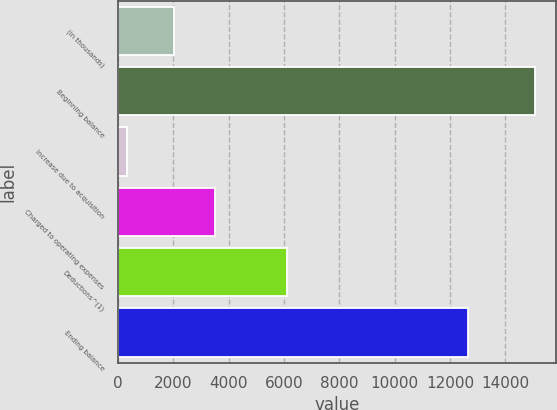Convert chart. <chart><loc_0><loc_0><loc_500><loc_500><bar_chart><fcel>(in thousands)<fcel>Beginning balance<fcel>Increase due to acquisition<fcel>Charged to operating expenses<fcel>Deductions^(1)<fcel>Ending balance<nl><fcel>2012<fcel>15080<fcel>325<fcel>3487.5<fcel>6118<fcel>12643<nl></chart> 